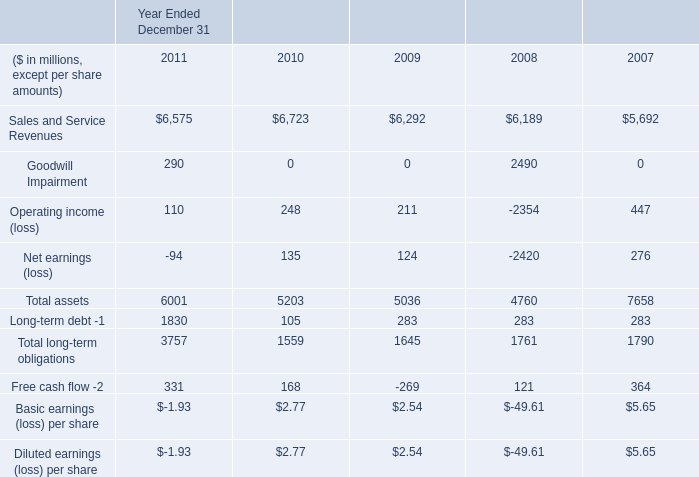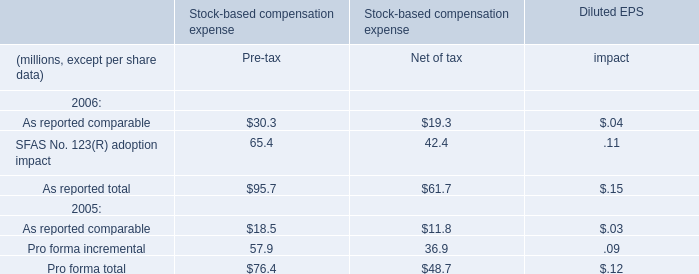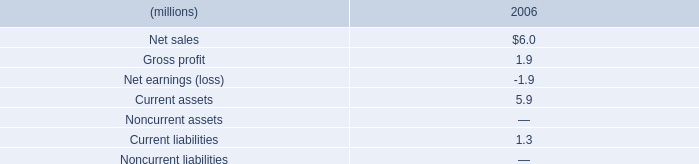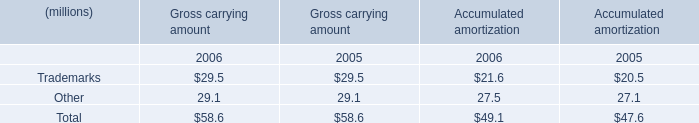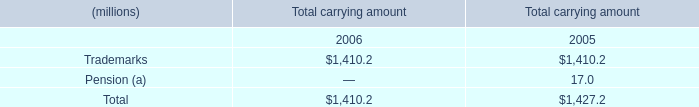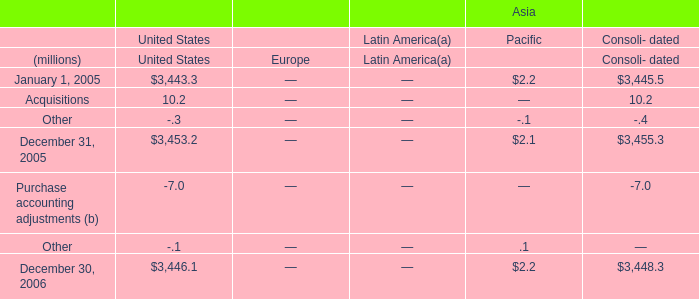What is the percentage of Trademarks in relation to the total in 2006? 
Computations: ((29.5 + 21.6) / (58.6 + 49.1))
Answer: 0.47447. 